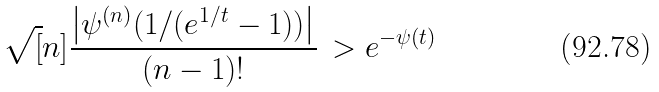Convert formula to latex. <formula><loc_0><loc_0><loc_500><loc_500>\sqrt { [ } n ] { \frac { \left | \psi ^ { ( n ) } ( 1 / ( e ^ { 1 / t } - 1 ) ) \right | } { ( n - 1 ) ! } } \, > e ^ { - \psi ( t ) }</formula> 